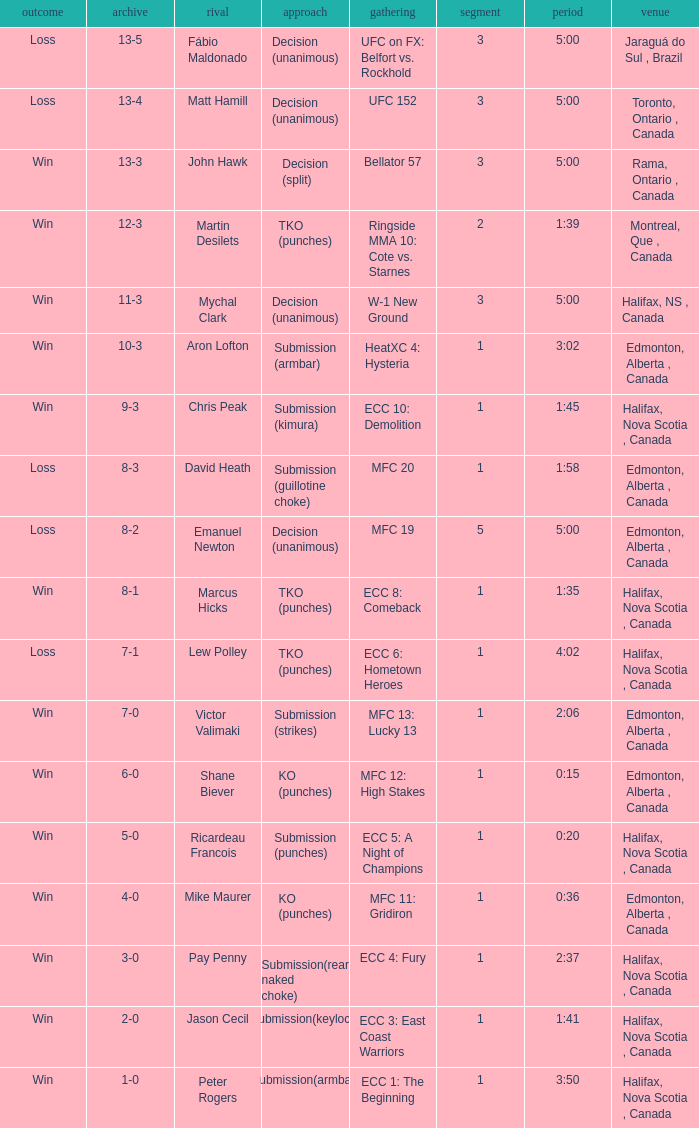What is the location of the match with Aron Lofton as the opponent? Edmonton, Alberta , Canada. 